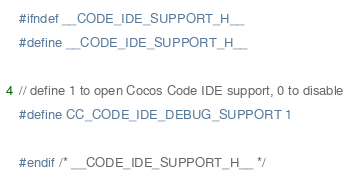Convert code to text. <code><loc_0><loc_0><loc_500><loc_500><_C_>#ifndef __CODE_IDE_SUPPORT_H__
#define __CODE_IDE_SUPPORT_H__

// define 1 to open Cocos Code IDE support, 0 to disable
#define CC_CODE_IDE_DEBUG_SUPPORT 1

#endif /* __CODE_IDE_SUPPORT_H__ */
</code> 